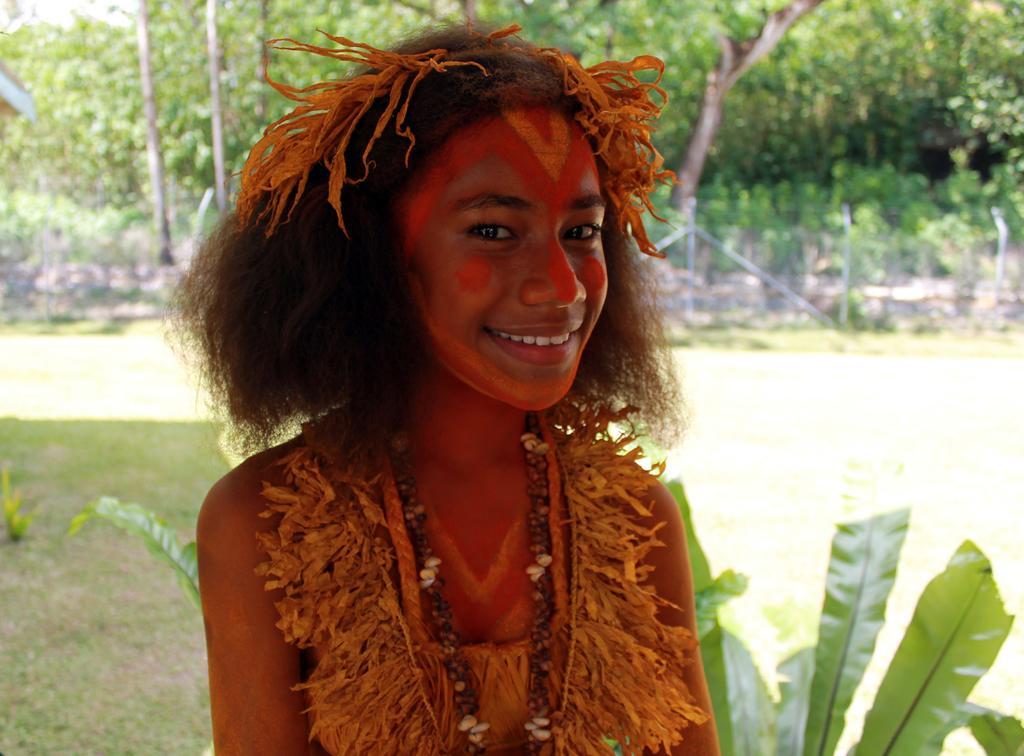Could you give a brief overview of what you see in this image? In this image, we can see a woman wearing a costume. She is watching and smiling. Background we can see grass, plants, fencing, poles and trees. 